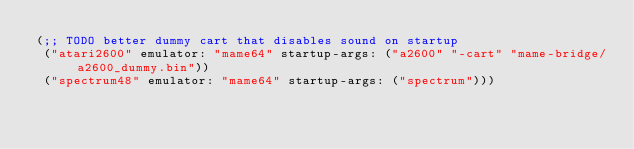<code> <loc_0><loc_0><loc_500><loc_500><_Scheme_>(;; TODO better dummy cart that disables sound on startup
 ("atari2600" emulator: "mame64" startup-args: ("a2600" "-cart" "mame-bridge/a2600_dummy.bin"))
 ("spectrum48" emulator: "mame64" startup-args: ("spectrum")))
</code> 